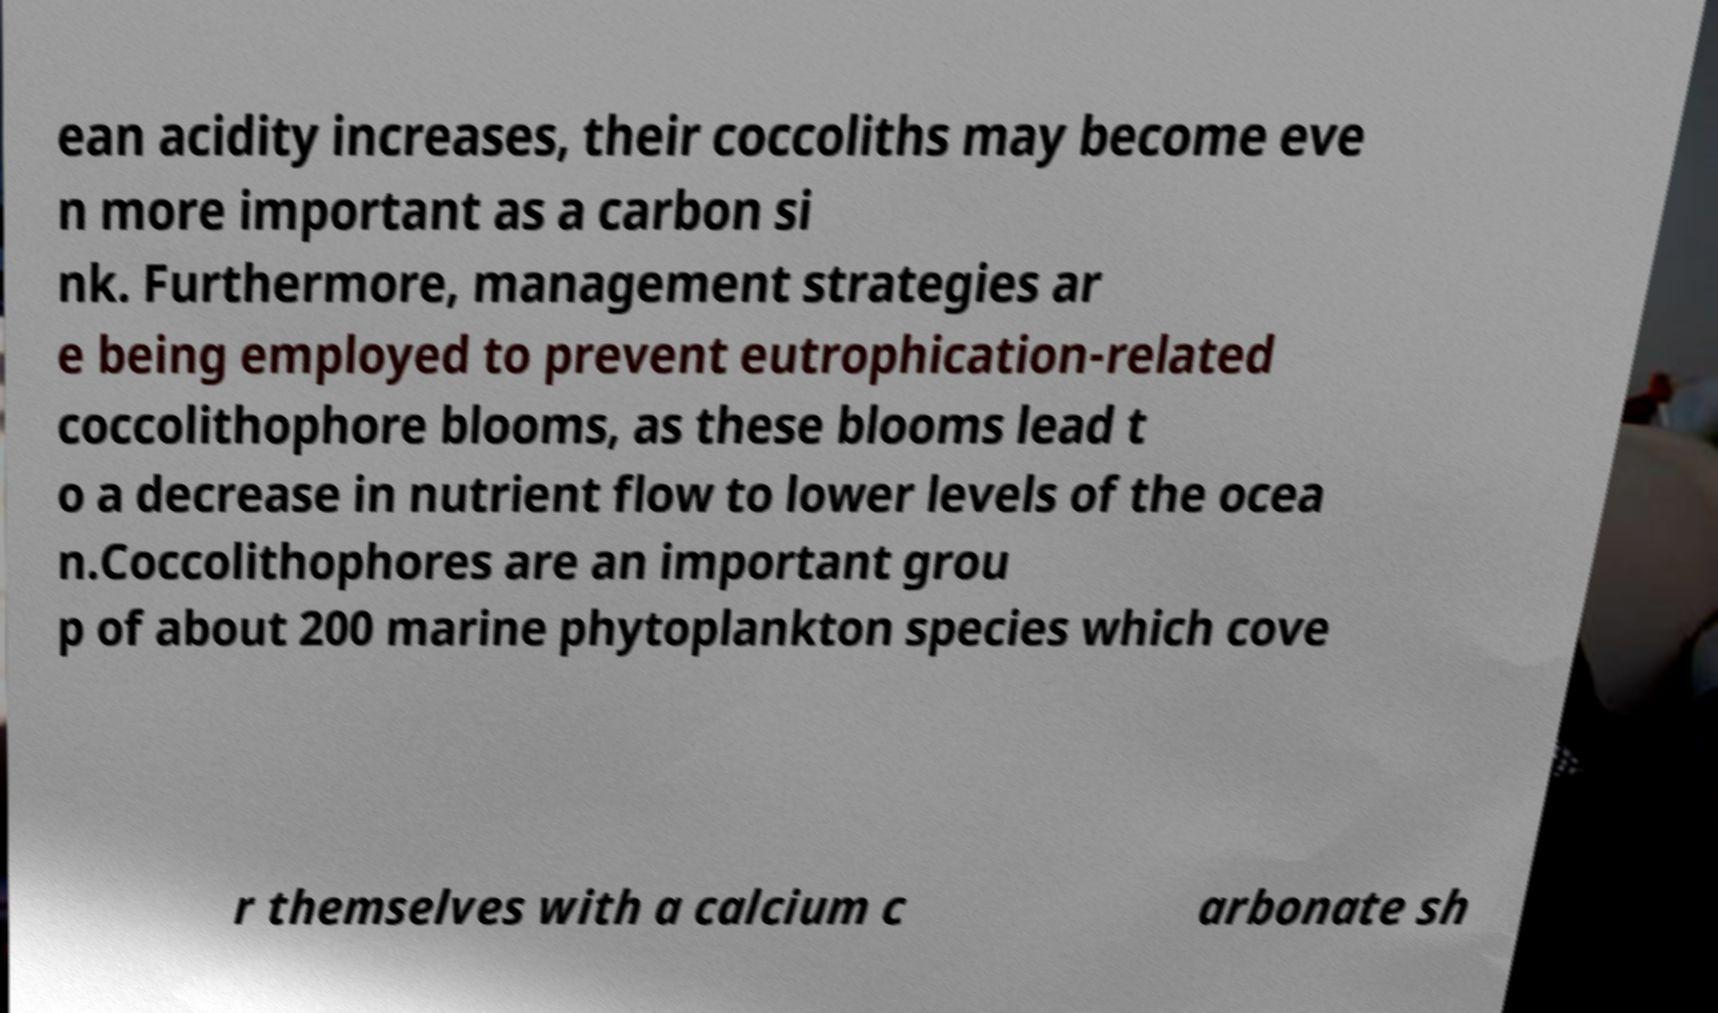Could you assist in decoding the text presented in this image and type it out clearly? ean acidity increases, their coccoliths may become eve n more important as a carbon si nk. Furthermore, management strategies ar e being employed to prevent eutrophication-related coccolithophore blooms, as these blooms lead t o a decrease in nutrient flow to lower levels of the ocea n.Coccolithophores are an important grou p of about 200 marine phytoplankton species which cove r themselves with a calcium c arbonate sh 